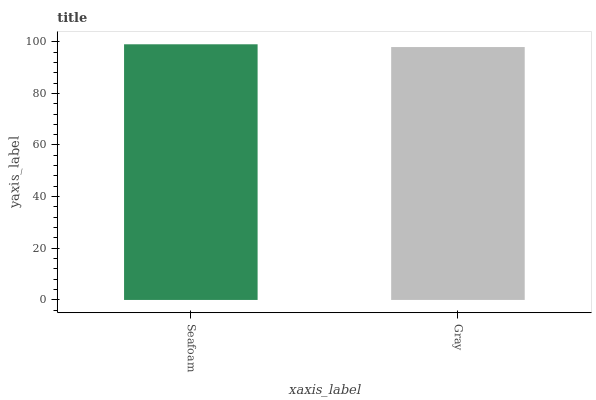Is Gray the minimum?
Answer yes or no. Yes. Is Seafoam the maximum?
Answer yes or no. Yes. Is Gray the maximum?
Answer yes or no. No. Is Seafoam greater than Gray?
Answer yes or no. Yes. Is Gray less than Seafoam?
Answer yes or no. Yes. Is Gray greater than Seafoam?
Answer yes or no. No. Is Seafoam less than Gray?
Answer yes or no. No. Is Seafoam the high median?
Answer yes or no. Yes. Is Gray the low median?
Answer yes or no. Yes. Is Gray the high median?
Answer yes or no. No. Is Seafoam the low median?
Answer yes or no. No. 